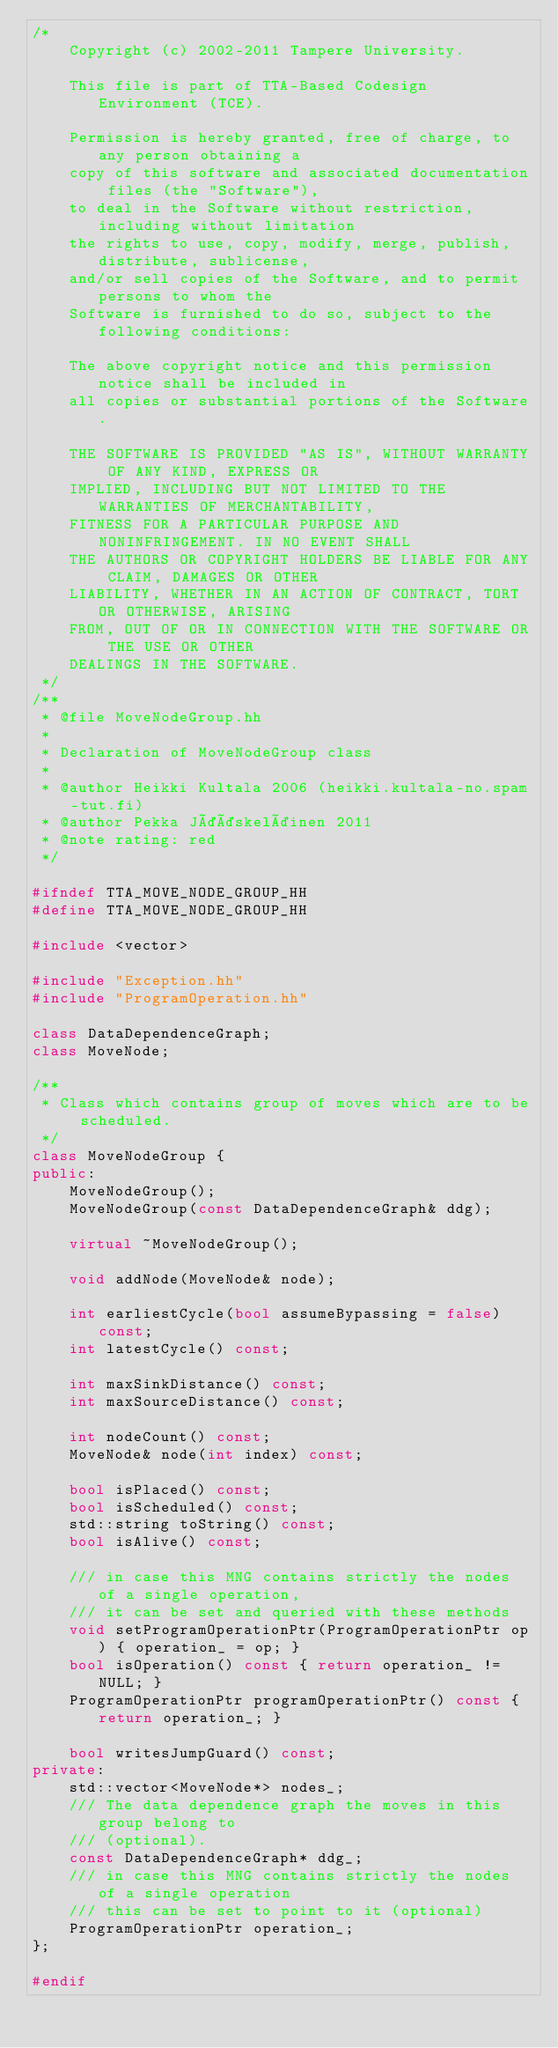Convert code to text. <code><loc_0><loc_0><loc_500><loc_500><_C++_>/*
    Copyright (c) 2002-2011 Tampere University.

    This file is part of TTA-Based Codesign Environment (TCE).

    Permission is hereby granted, free of charge, to any person obtaining a
    copy of this software and associated documentation files (the "Software"),
    to deal in the Software without restriction, including without limitation
    the rights to use, copy, modify, merge, publish, distribute, sublicense,
    and/or sell copies of the Software, and to permit persons to whom the
    Software is furnished to do so, subject to the following conditions:

    The above copyright notice and this permission notice shall be included in
    all copies or substantial portions of the Software.

    THE SOFTWARE IS PROVIDED "AS IS", WITHOUT WARRANTY OF ANY KIND, EXPRESS OR
    IMPLIED, INCLUDING BUT NOT LIMITED TO THE WARRANTIES OF MERCHANTABILITY,
    FITNESS FOR A PARTICULAR PURPOSE AND NONINFRINGEMENT. IN NO EVENT SHALL
    THE AUTHORS OR COPYRIGHT HOLDERS BE LIABLE FOR ANY CLAIM, DAMAGES OR OTHER
    LIABILITY, WHETHER IN AN ACTION OF CONTRACT, TORT OR OTHERWISE, ARISING
    FROM, OUT OF OR IN CONNECTION WITH THE SOFTWARE OR THE USE OR OTHER
    DEALINGS IN THE SOFTWARE.
 */
/**
 * @file MoveNodeGroup.hh
 * 
 * Declaration of MoveNodeGroup class 
 * 
 * @author Heikki Kultala 2006 (heikki.kultala-no.spam-tut.fi)
 * @author Pekka Jääskeläinen 2011
 * @note rating: red
 */

#ifndef TTA_MOVE_NODE_GROUP_HH
#define TTA_MOVE_NODE_GROUP_HH

#include <vector>

#include "Exception.hh"
#include "ProgramOperation.hh"

class DataDependenceGraph;
class MoveNode;

/**
 * Class which contains group of moves which are to be scheduled.
 */
class MoveNodeGroup {
public:
    MoveNodeGroup();
    MoveNodeGroup(const DataDependenceGraph& ddg);

    virtual ~MoveNodeGroup();

    void addNode(MoveNode& node);
    
    int earliestCycle(bool assumeBypassing = false) const;
    int latestCycle() const;

    int maxSinkDistance() const;
    int maxSourceDistance() const;

    int nodeCount() const;
    MoveNode& node(int index) const;

    bool isPlaced() const;
    bool isScheduled() const;
    std::string toString() const;
    bool isAlive() const;

    /// in case this MNG contains strictly the nodes of a single operation,
    /// it can be set and queried with these methods
    void setProgramOperationPtr(ProgramOperationPtr op) { operation_ = op; }
    bool isOperation() const { return operation_ != NULL; }
    ProgramOperationPtr programOperationPtr() const { return operation_; }

    bool writesJumpGuard() const;
private:
    std::vector<MoveNode*> nodes_;
    /// The data dependence graph the moves in this group belong to 
    /// (optional).
    const DataDependenceGraph* ddg_;
    /// in case this MNG contains strictly the nodes of a single operation
    /// this can be set to point to it (optional)
    ProgramOperationPtr operation_;
};

#endif
</code> 